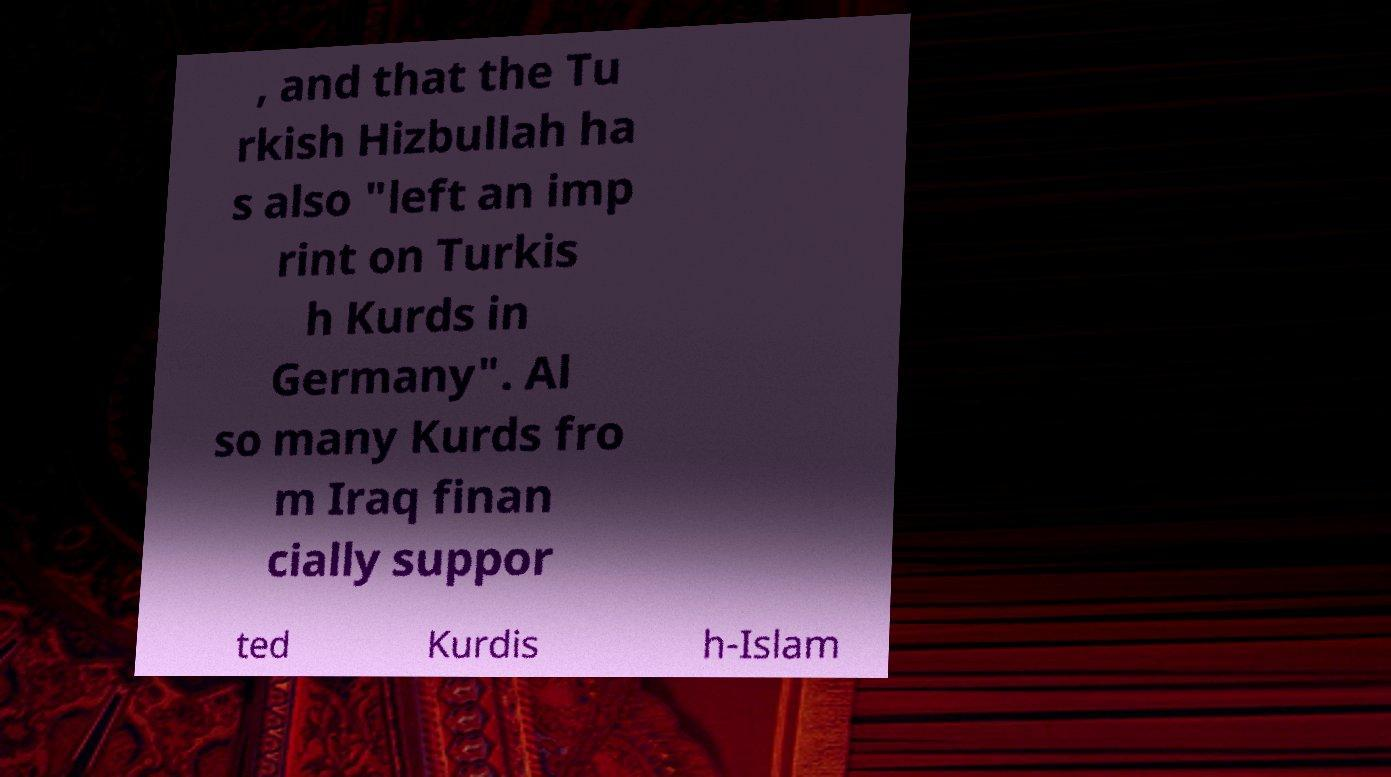There's text embedded in this image that I need extracted. Can you transcribe it verbatim? , and that the Tu rkish Hizbullah ha s also "left an imp rint on Turkis h Kurds in Germany". Al so many Kurds fro m Iraq finan cially suppor ted Kurdis h-Islam 